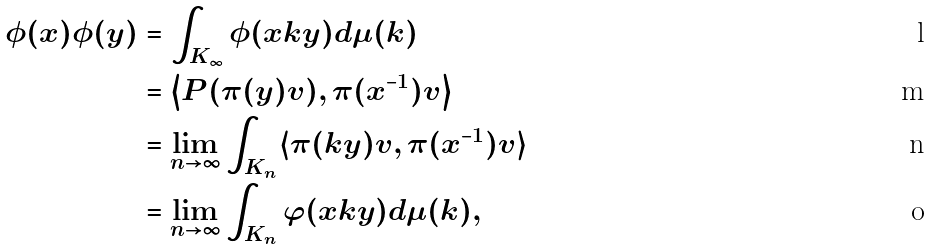<formula> <loc_0><loc_0><loc_500><loc_500>\phi ( x ) \phi ( y ) & = \int _ { K _ { \infty } } \phi ( x k y ) d \mu ( k ) \\ & = \left \langle P ( \pi ( y ) v ) , \pi ( x ^ { - 1 } ) v \right \rangle \\ & = \lim _ { n \rightarrow \infty } \int _ { K _ { n } } \langle \pi ( k y ) v , \pi ( x ^ { - 1 } ) v \rangle \\ & = \lim _ { n \rightarrow \infty } \int _ { K _ { n } } \varphi ( x k y ) d \mu ( k ) ,</formula> 